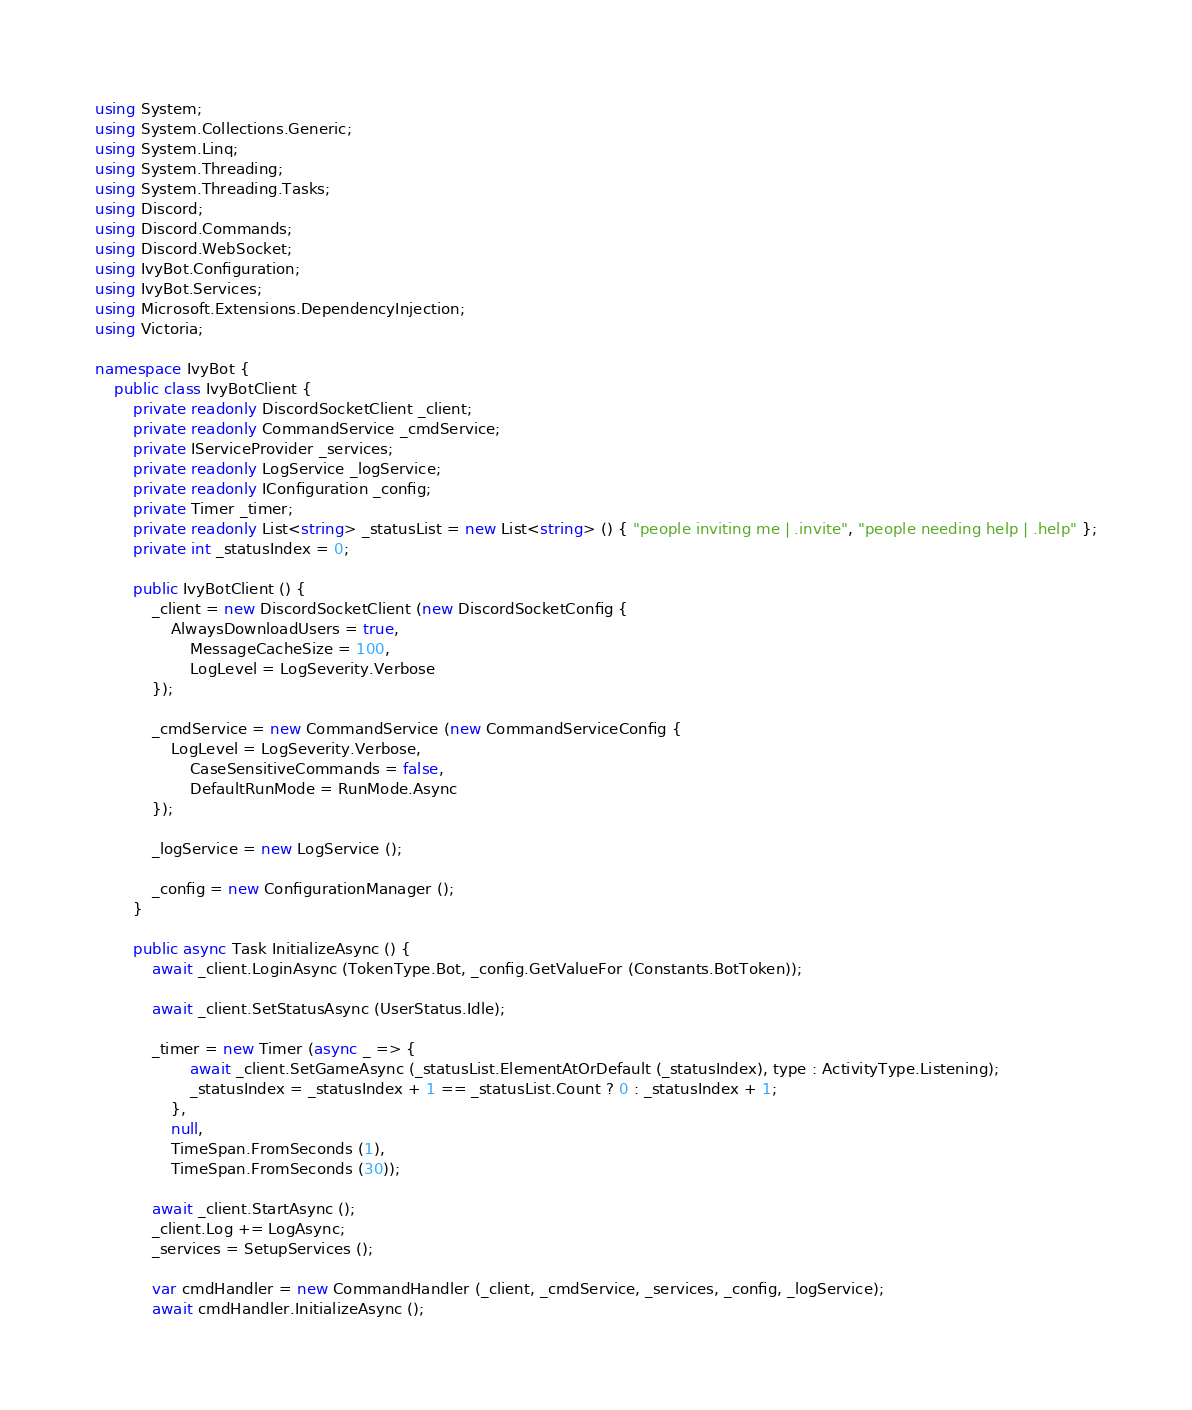Convert code to text. <code><loc_0><loc_0><loc_500><loc_500><_C#_>using System;
using System.Collections.Generic;
using System.Linq;
using System.Threading;
using System.Threading.Tasks;
using Discord;
using Discord.Commands;
using Discord.WebSocket;
using IvyBot.Configuration;
using IvyBot.Services;
using Microsoft.Extensions.DependencyInjection;
using Victoria;

namespace IvyBot {
    public class IvyBotClient {
        private readonly DiscordSocketClient _client;
        private readonly CommandService _cmdService;
        private IServiceProvider _services;
        private readonly LogService _logService;
        private readonly IConfiguration _config;
        private Timer _timer;
        private readonly List<string> _statusList = new List<string> () { "people inviting me | .invite", "people needing help | .help" };
        private int _statusIndex = 0;

        public IvyBotClient () {
            _client = new DiscordSocketClient (new DiscordSocketConfig {
                AlwaysDownloadUsers = true,
                    MessageCacheSize = 100,
                    LogLevel = LogSeverity.Verbose
            });

            _cmdService = new CommandService (new CommandServiceConfig {
                LogLevel = LogSeverity.Verbose,
                    CaseSensitiveCommands = false,
                    DefaultRunMode = RunMode.Async
            });

            _logService = new LogService ();

            _config = new ConfigurationManager ();
        }

        public async Task InitializeAsync () {
            await _client.LoginAsync (TokenType.Bot, _config.GetValueFor (Constants.BotToken));

            await _client.SetStatusAsync (UserStatus.Idle);

            _timer = new Timer (async _ => {
                    await _client.SetGameAsync (_statusList.ElementAtOrDefault (_statusIndex), type : ActivityType.Listening);
                    _statusIndex = _statusIndex + 1 == _statusList.Count ? 0 : _statusIndex + 1;
                },
                null,
                TimeSpan.FromSeconds (1),
                TimeSpan.FromSeconds (30));

            await _client.StartAsync ();
            _client.Log += LogAsync;
            _services = SetupServices ();

            var cmdHandler = new CommandHandler (_client, _cmdService, _services, _config, _logService);
            await cmdHandler.InitializeAsync ();
</code> 